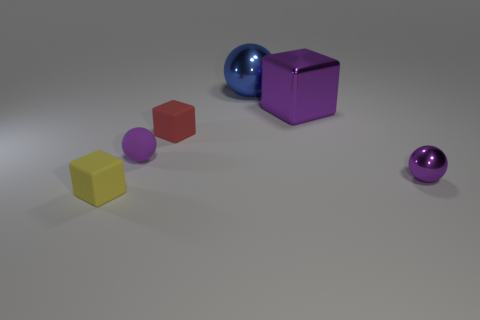Add 2 brown shiny objects. How many objects exist? 8 Subtract 0 gray blocks. How many objects are left? 6 Subtract all purple shiny cubes. Subtract all purple metal spheres. How many objects are left? 4 Add 3 purple shiny objects. How many purple shiny objects are left? 5 Add 6 tiny brown cylinders. How many tiny brown cylinders exist? 6 